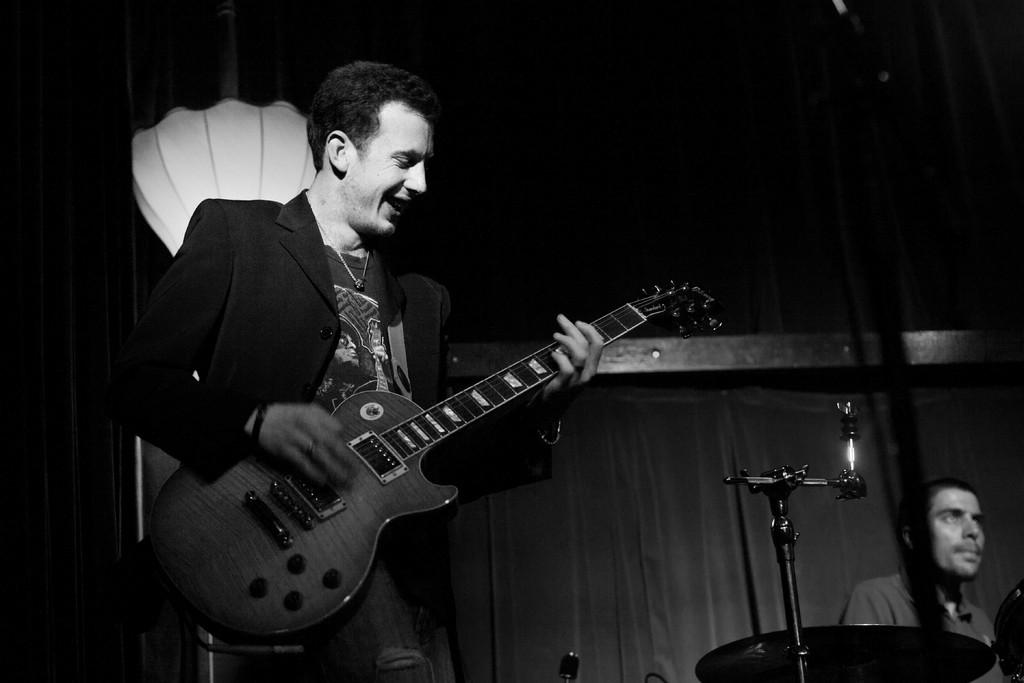What is the man in the image doing? The man is playing the guitar. What is the man wearing in the image? The man is wearing a coat. What object is the man holding in the image? The man is holding a guitar. What can be seen in the background of the image? There is a curtain, a stand, and a person in the background of the image. What type of butter is being used to play the guitar in the image? There is no butter present in the image, and it is not being used to play the guitar. 